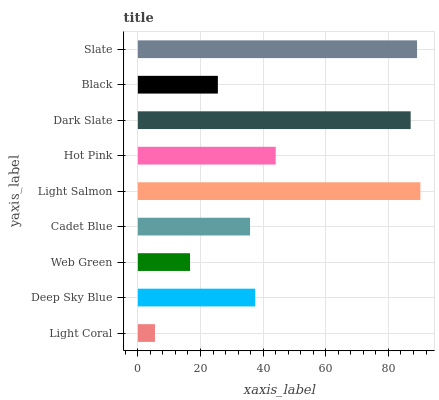Is Light Coral the minimum?
Answer yes or no. Yes. Is Light Salmon the maximum?
Answer yes or no. Yes. Is Deep Sky Blue the minimum?
Answer yes or no. No. Is Deep Sky Blue the maximum?
Answer yes or no. No. Is Deep Sky Blue greater than Light Coral?
Answer yes or no. Yes. Is Light Coral less than Deep Sky Blue?
Answer yes or no. Yes. Is Light Coral greater than Deep Sky Blue?
Answer yes or no. No. Is Deep Sky Blue less than Light Coral?
Answer yes or no. No. Is Deep Sky Blue the high median?
Answer yes or no. Yes. Is Deep Sky Blue the low median?
Answer yes or no. Yes. Is Dark Slate the high median?
Answer yes or no. No. Is Black the low median?
Answer yes or no. No. 